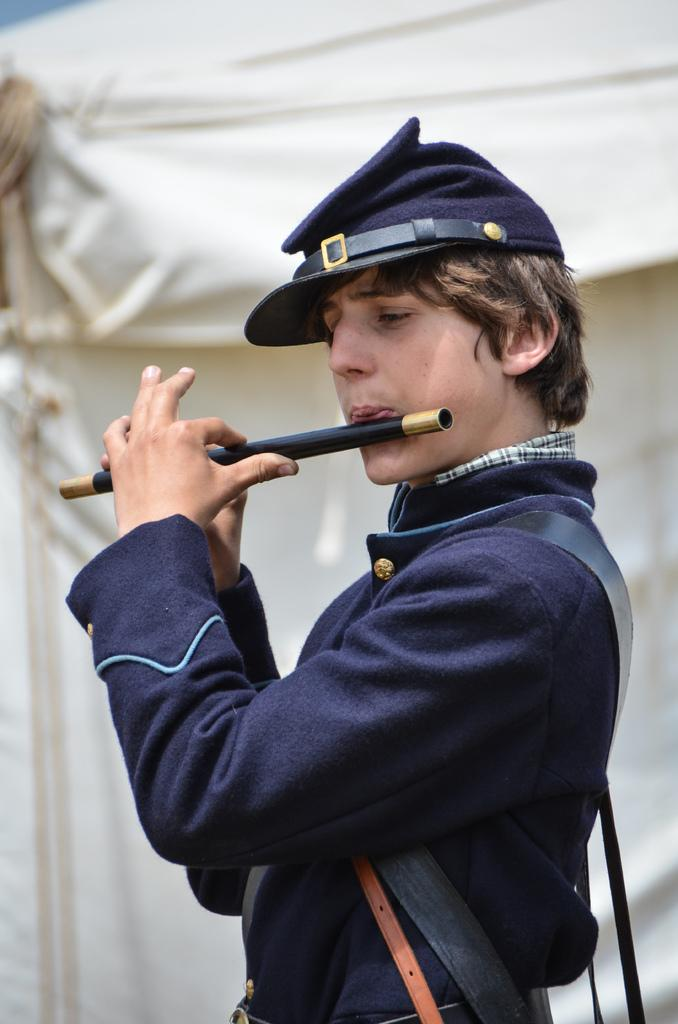What is the main subject of the image? There is a person in the image. What is the person wearing? The person is wearing a blue dress. What is the person doing in the image? The person is playing a flute. What color is the background of the image? The background of the image is white in color. How many feathers can be seen attached to the hook in the image? There is no hook or feathers present in the image; it features a person playing a flute against a white background. 